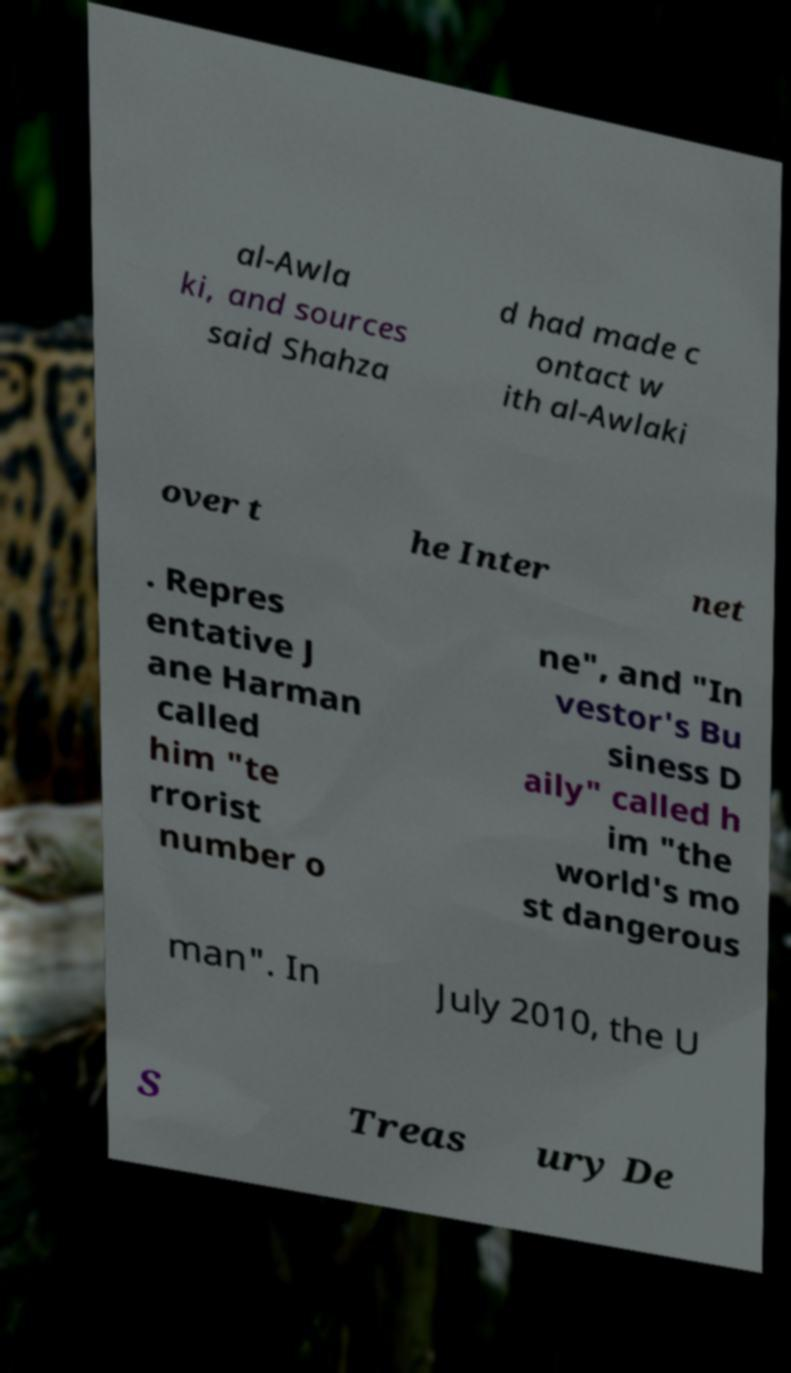Could you extract and type out the text from this image? al-Awla ki, and sources said Shahza d had made c ontact w ith al-Awlaki over t he Inter net . Repres entative J ane Harman called him "te rrorist number o ne", and "In vestor's Bu siness D aily" called h im "the world's mo st dangerous man". In July 2010, the U S Treas ury De 